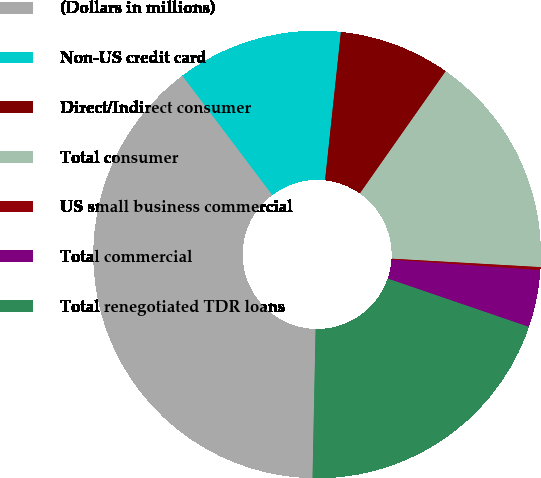<chart> <loc_0><loc_0><loc_500><loc_500><pie_chart><fcel>(Dollars in millions)<fcel>Non-US credit card<fcel>Direct/Indirect consumer<fcel>Total consumer<fcel>US small business commercial<fcel>Total commercial<fcel>Total renegotiated TDR loans<nl><fcel>39.4%<fcel>11.97%<fcel>8.05%<fcel>16.16%<fcel>0.22%<fcel>4.13%<fcel>20.08%<nl></chart> 